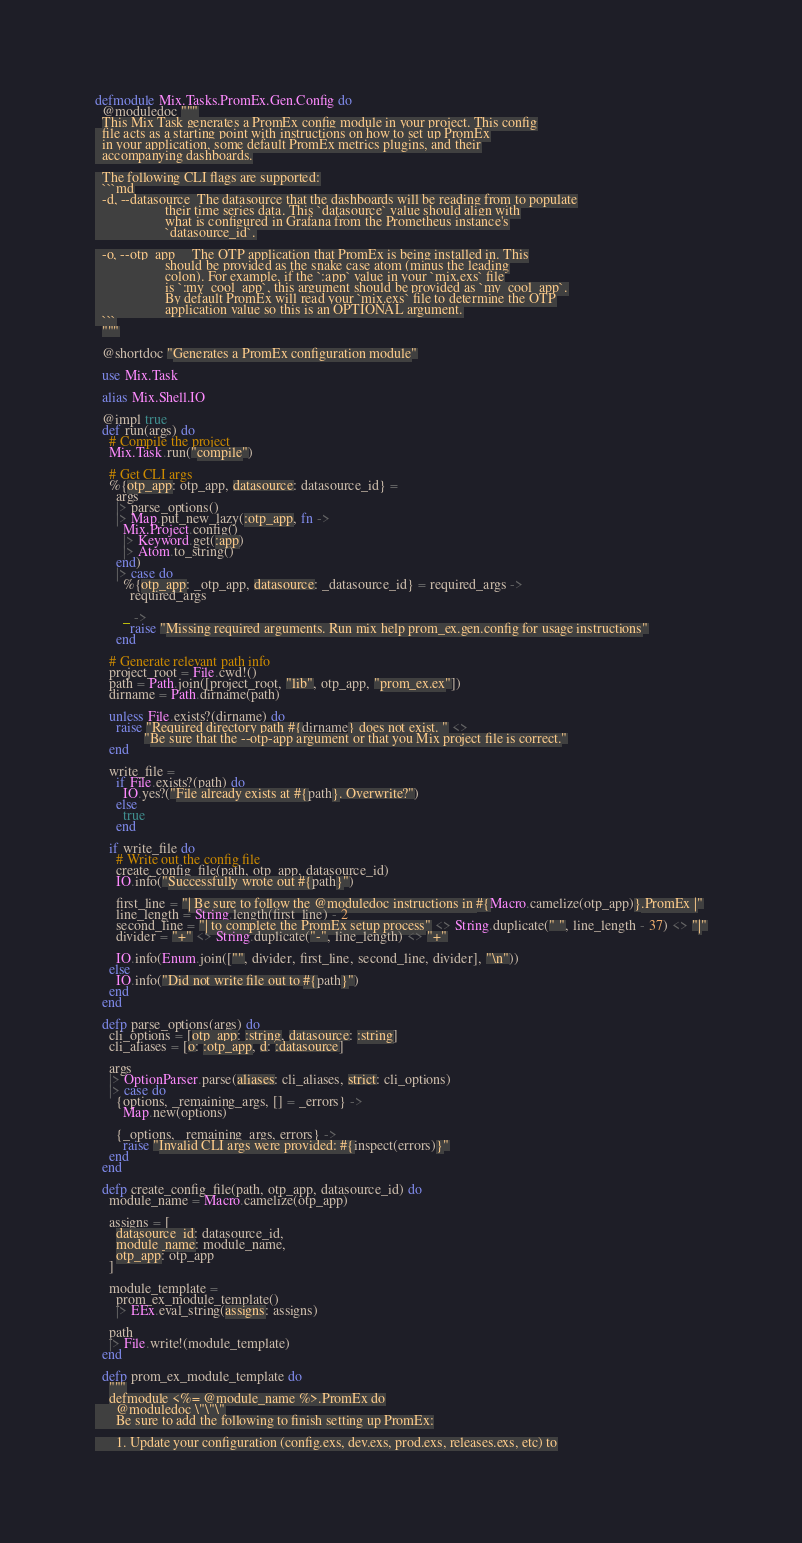<code> <loc_0><loc_0><loc_500><loc_500><_Elixir_>defmodule Mix.Tasks.PromEx.Gen.Config do
  @moduledoc """
  This Mix Task generates a PromEx config module in your project. This config
  file acts as a starting point with instructions on how to set up PromEx
  in your application, some default PromEx metrics plugins, and their
  accompanying dashboards.

  The following CLI flags are supported:
  ```md
  -d, --datasource  The datasource that the dashboards will be reading from to populate
                    their time series data. This `datasource` value should align with
                    what is configured in Grafana from the Prometheus instance's
                    `datasource_id`.

  -o, --otp_app     The OTP application that PromEx is being installed in. This
                    should be provided as the snake case atom (minus the leading
                    colon). For example, if the `:app` value in your `mix.exs` file
                    is `:my_cool_app`, this argument should be provided as `my_cool_app`.
                    By default PromEx will read your `mix.exs` file to determine the OTP
                    application value so this is an OPTIONAL argument.
  ```
  """

  @shortdoc "Generates a PromEx configuration module"

  use Mix.Task

  alias Mix.Shell.IO

  @impl true
  def run(args) do
    # Compile the project
    Mix.Task.run("compile")

    # Get CLI args
    %{otp_app: otp_app, datasource: datasource_id} =
      args
      |> parse_options()
      |> Map.put_new_lazy(:otp_app, fn ->
        Mix.Project.config()
        |> Keyword.get(:app)
        |> Atom.to_string()
      end)
      |> case do
        %{otp_app: _otp_app, datasource: _datasource_id} = required_args ->
          required_args

        _ ->
          raise "Missing required arguments. Run mix help prom_ex.gen.config for usage instructions"
      end

    # Generate relevant path info
    project_root = File.cwd!()
    path = Path.join([project_root, "lib", otp_app, "prom_ex.ex"])
    dirname = Path.dirname(path)

    unless File.exists?(dirname) do
      raise "Required directory path #{dirname} does not exist. " <>
              "Be sure that the --otp-app argument or that you Mix project file is correct."
    end

    write_file =
      if File.exists?(path) do
        IO.yes?("File already exists at #{path}. Overwrite?")
      else
        true
      end

    if write_file do
      # Write out the config file
      create_config_file(path, otp_app, datasource_id)
      IO.info("Successfully wrote out #{path}")

      first_line = "| Be sure to follow the @moduledoc instructions in #{Macro.camelize(otp_app)}.PromEx |"
      line_length = String.length(first_line) - 2
      second_line = "| to complete the PromEx setup process" <> String.duplicate(" ", line_length - 37) <> "|"
      divider = "+" <> String.duplicate("-", line_length) <> "+"

      IO.info(Enum.join(["", divider, first_line, second_line, divider], "\n"))
    else
      IO.info("Did not write file out to #{path}")
    end
  end

  defp parse_options(args) do
    cli_options = [otp_app: :string, datasource: :string]
    cli_aliases = [o: :otp_app, d: :datasource]

    args
    |> OptionParser.parse(aliases: cli_aliases, strict: cli_options)
    |> case do
      {options, _remaining_args, [] = _errors} ->
        Map.new(options)

      {_options, _remaining_args, errors} ->
        raise "Invalid CLI args were provided: #{inspect(errors)}"
    end
  end

  defp create_config_file(path, otp_app, datasource_id) do
    module_name = Macro.camelize(otp_app)

    assigns = [
      datasource_id: datasource_id,
      module_name: module_name,
      otp_app: otp_app
    ]

    module_template =
      prom_ex_module_template()
      |> EEx.eval_string(assigns: assigns)

    path
    |> File.write!(module_template)
  end

  defp prom_ex_module_template do
    """
    defmodule <%= @module_name %>.PromEx do
      @moduledoc \"\"\"
      Be sure to add the following to finish setting up PromEx:

      1. Update your configuration (config.exs, dev.exs, prod.exs, releases.exs, etc) to</code> 